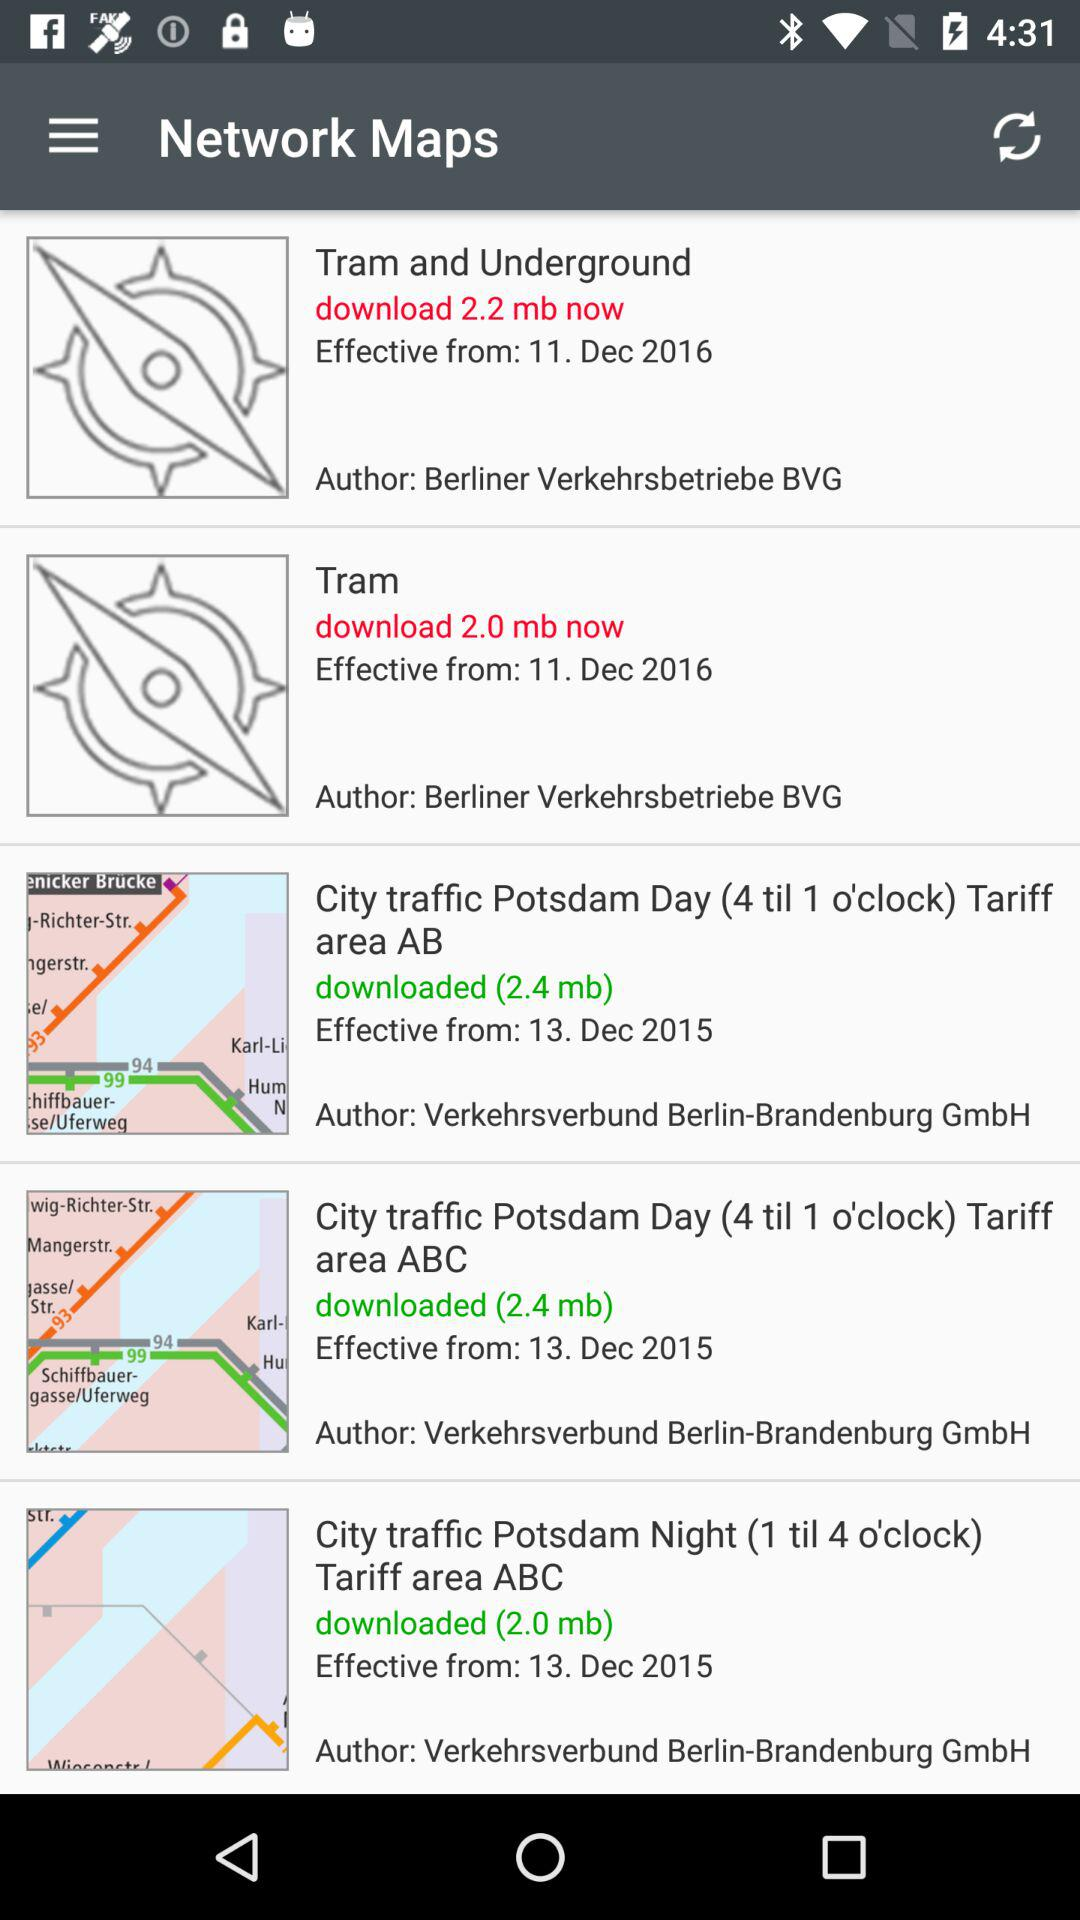What is the effective date of "Tram and Underground"? The effective date of "Tram and Underground" is December 11, 2016. 